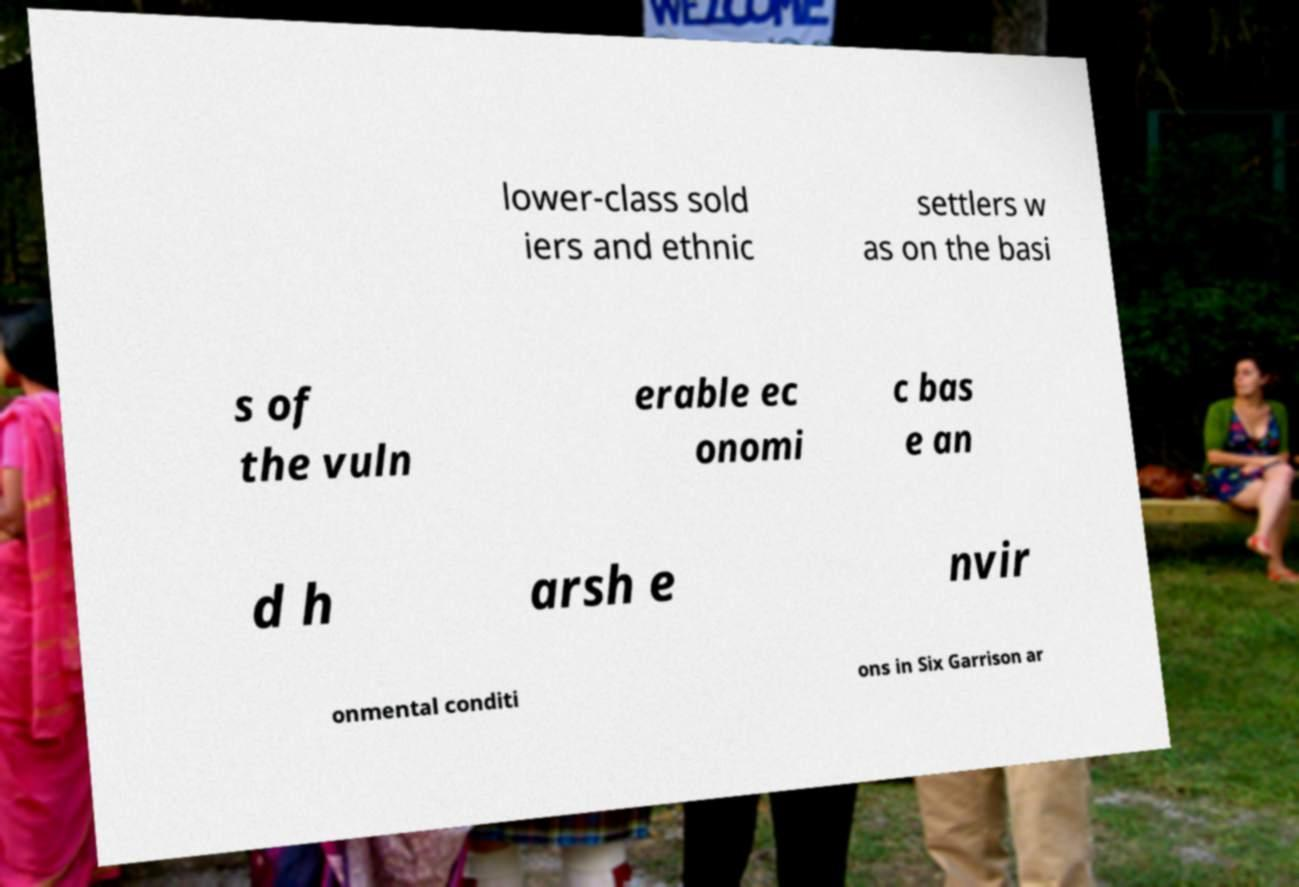There's text embedded in this image that I need extracted. Can you transcribe it verbatim? lower-class sold iers and ethnic settlers w as on the basi s of the vuln erable ec onomi c bas e an d h arsh e nvir onmental conditi ons in Six Garrison ar 